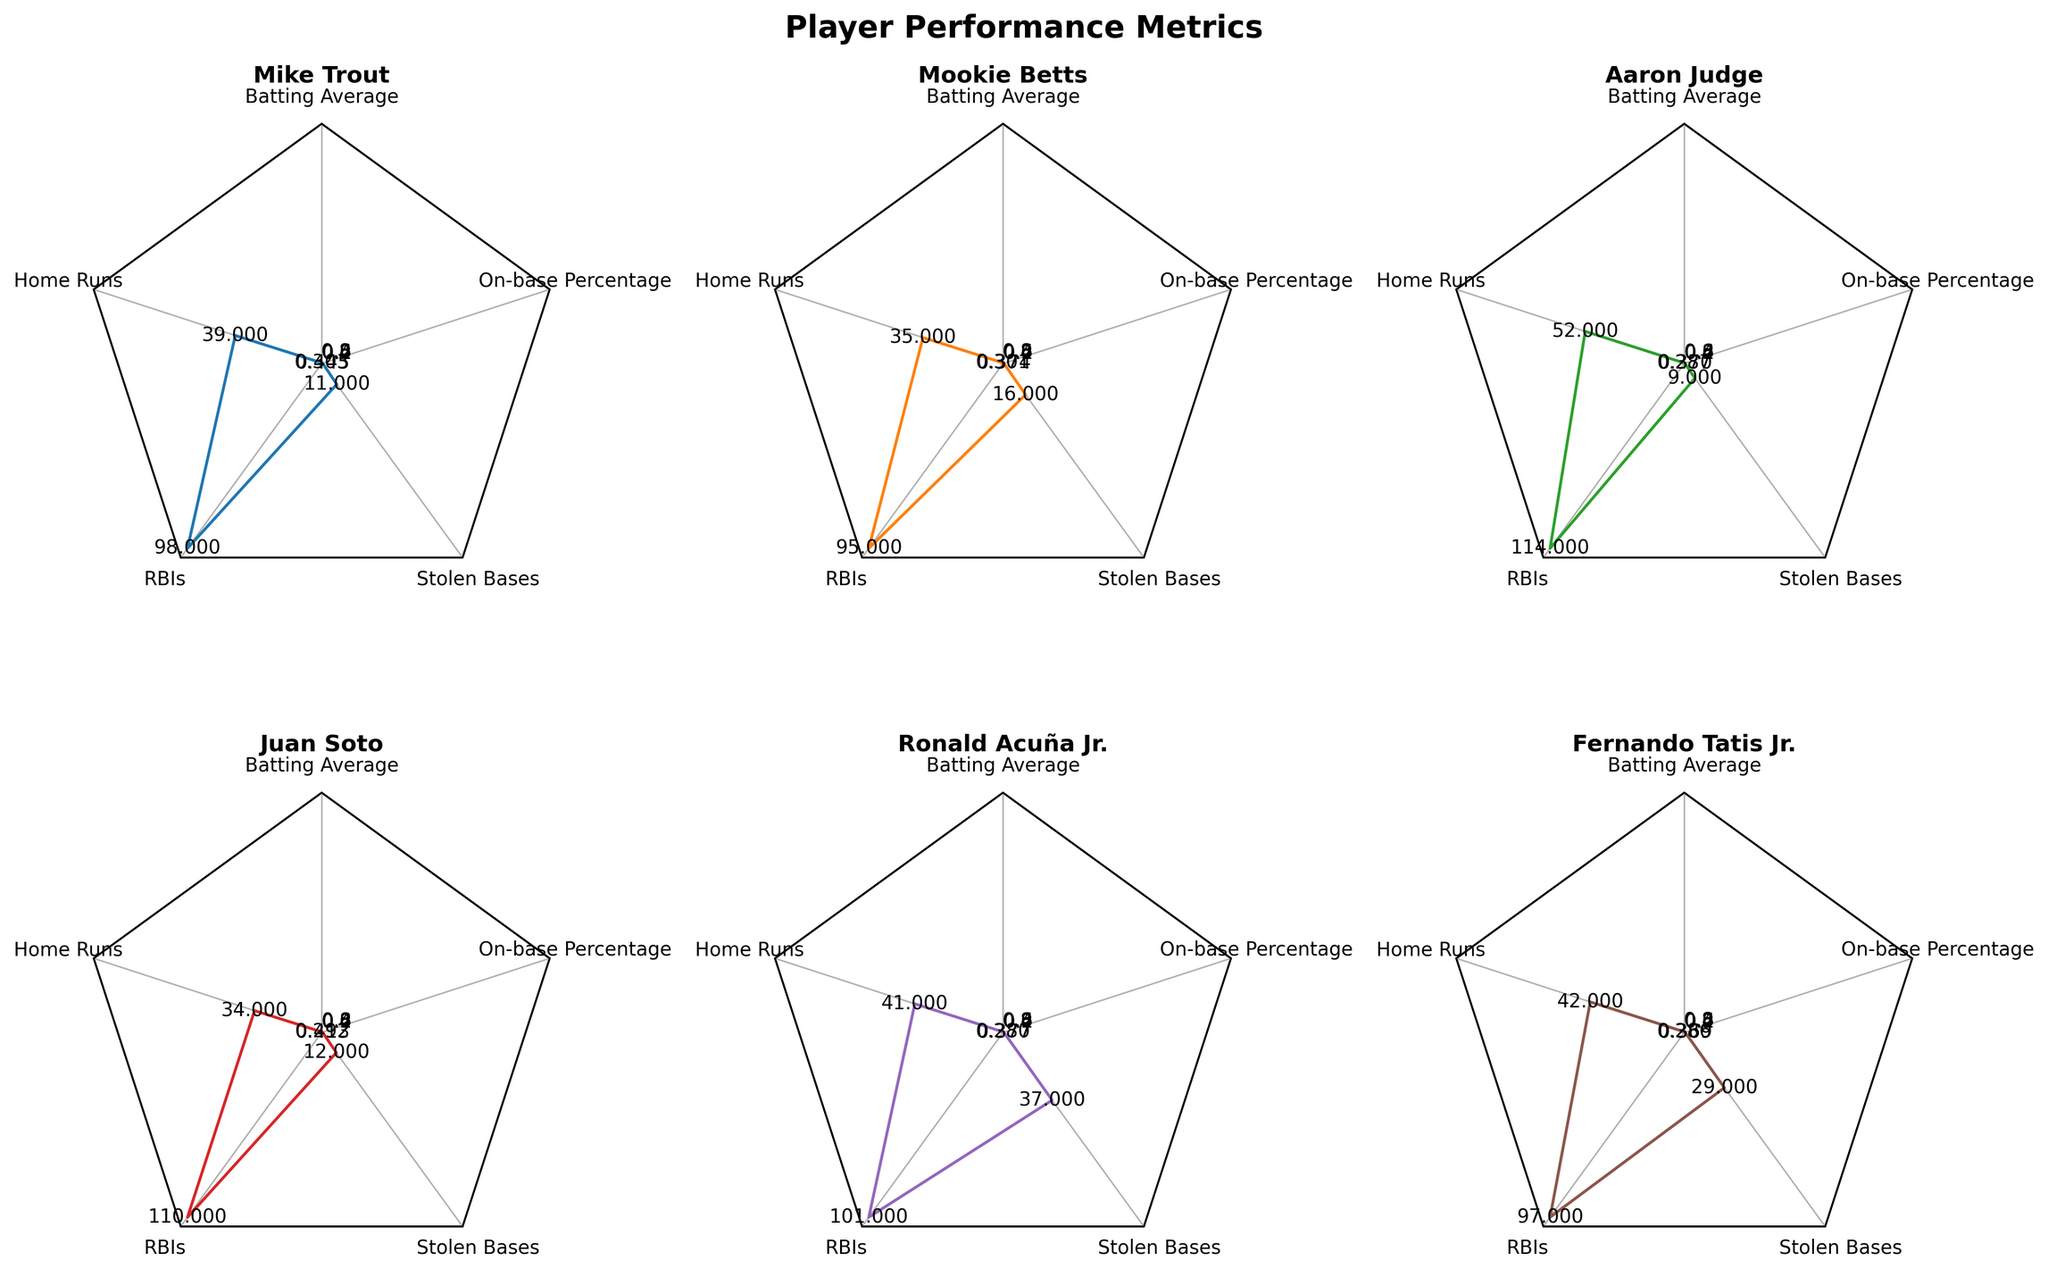Who has the highest number of Home Runs? The radar chart plots the Home Runs metric for each player, visualized as one of the axes extending from the center. By comparing the values along this axis, Aaron Judge has the highest number of Home Runs at 52.
Answer: Aaron Judge Which player has the lowest Batting Average? The Batting Average is one of the metrics plotted in the radar chart. By examining the chart, Ronald Acuña Jr. has the lowest Batting Average at 0.280.
Answer: Ronald Acuña Jr How does Fernando Tatis Jr.'s On-base Percentage compare to Juan Soto's? The On-base Percentage for each player is plotted on the radar chart. By comparing the charts, Juan Soto has a higher On-base Percentage (0.413) than Fernando Tatis Jr. (0.369).
Answer: Juan Soto's is higher Which player leads in Stolen Bases, and by how much compared to the player with the 2nd most? Ronald Acuña Jr. leads in Stolen Bases with 37. The second highest is Fernando Tatis Jr. with 29. Thus, Ronald Acuña Jr. leads by 37 - 29 = 8 Stolen Bases.
Answer: Ronald Acuña Jr. by 8 Who has the smallest values in both Home Runs and Stolen Bases? By looking at the radar charts, the player with the smallest values in both metrics can be identified. Mookie Betts has the smallest values in both Home Runs (35) and Stolen Bases (16).
Answer: Mookie Betts What is the difference in RBIs between Aaron Judge and Mike Trout? Using the radar charts, the RBIs for Aaron Judge (114) and Mike Trout (98) can be seen. The difference is 114 - 98 = 16 RBIs.
Answer: 16 How do the RBIs of Juan Soto and Ronald Acuña Jr. compare? By looking at the radar charts, Juan Soto's RBIs are 110 and Ronald Acuña Jr.'s RBIs are 101. This shows that Juan Soto has more RBIs.
Answer: Juan Soto has more Which player has the best combination of Batting Average and On-base Percentage? By comparing both metrics on the radar charts, it is evident that Mike Trout has the best overall combination with a Batting Average of 0.303 and an On-base Percentage of 0.445.
Answer: Mike Trout 